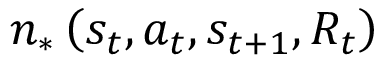<formula> <loc_0><loc_0><loc_500><loc_500>{ n _ { * } } \left ( { { s _ { t } } , { a _ { t } } , { s _ { t + 1 } } , { R _ { t } } } \right )</formula> 